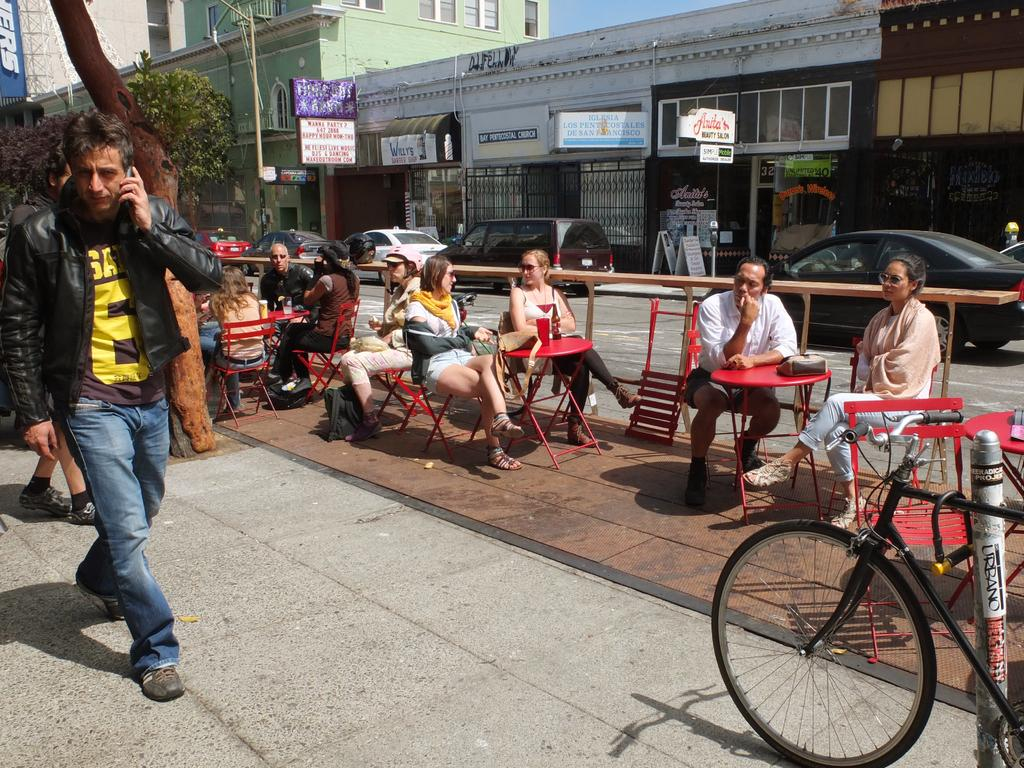What type of natural element is present in the image? There is a tree in the image. What type of man-made structures can be seen in the image? There are buildings in the image. What type of signage is present in the image? There is a poster and a banner in the image. What is the man in the image doing? The man is standing on the road. What are the people in the image doing? The people are sitting on chairs. What type of transportation is present in the image? There are cars on the road. How many legs does the tree have in the image? Trees do not have legs; they have trunks and branches. What type of plantation is visible in the image? There is no plantation present in the image. 